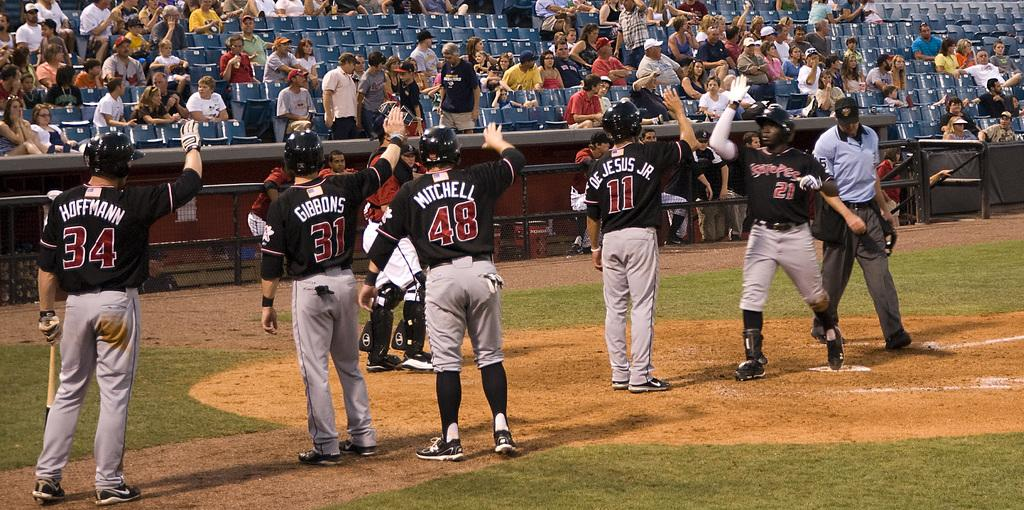<image>
Create a compact narrative representing the image presented. Players 34, 31, 46,  and 11 are facing the crowd. 